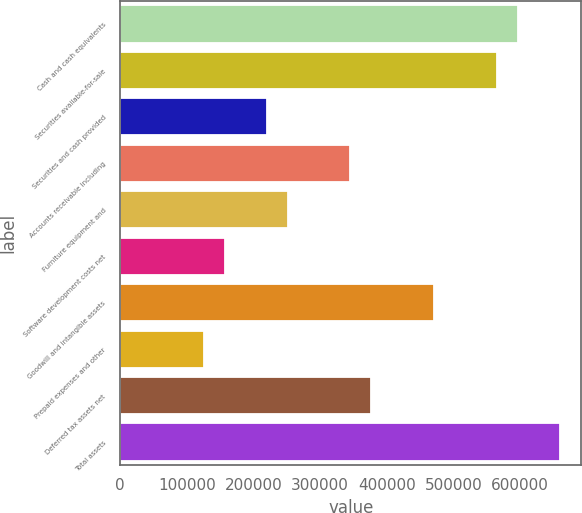Convert chart. <chart><loc_0><loc_0><loc_500><loc_500><bar_chart><fcel>Cash and cash equivalents<fcel>Securities available-for-sale<fcel>Securities and cash provided<fcel>Accounts receivable including<fcel>Furniture equipment and<fcel>Software development costs net<fcel>Goodwill and intangible assets<fcel>Prepaid expenses and other<fcel>Deferred tax assets net<fcel>Total assets<nl><fcel>596394<fcel>565006<fcel>219730<fcel>345285<fcel>251119<fcel>156952<fcel>470840<fcel>125564<fcel>376673<fcel>659172<nl></chart> 